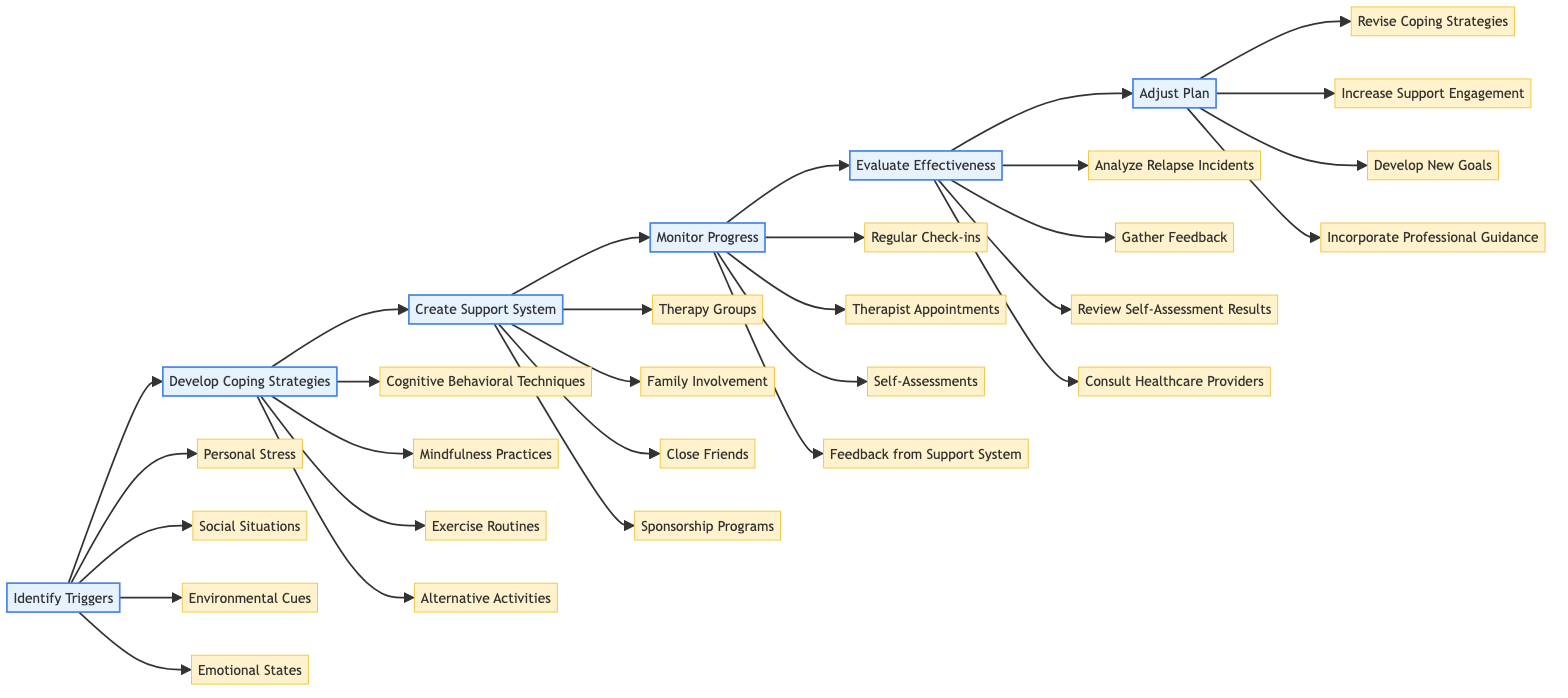What is the first step in the relapse prevention strategy? The first step in the flowchart is represented by the node labeled "Identify Triggers." This is the starting point of the horizontal flowchart.
Answer: Identify Triggers How many detailed points are listed under "Create Support System"? The "Create Support System" step has four detailed points listed below it, which are represented as nodes connected to it in the diagram.
Answer: 4 What are three examples of triggers identified in the diagram? The diagram provides four examples under the "Identify Triggers" step, such as Personal Stress, Social Situations, and Emotional States. Any three of these could be a valid answer to this question.
Answer: Personal Stress, Social Situations, Emotional States What comes after "Monitor Progress"? The next step after "Monitor Progress," which is placed further along the flowchart, is "Evaluate Effectiveness." This indicates the next action in the sequence.
Answer: Evaluate Effectiveness How does "Adjust Plan" relate to "Evaluate Effectiveness"? In the flowchart, "Adjust Plan" follows "Evaluate Effectiveness," indicating that it is the subsequent step that comes after evaluating how effective the previously implemented strategies have been.
Answer: Adjust Plan What is one method under "Develop Coping Strategies"? The "Develop Coping Strategies" step includes several methods in the detailed points, one of which is "Mindfulness Practices." This is one example of a coping strategy outlined in the diagram.
Answer: Mindfulness Practices What is the last detailed point listed under "Evaluate Effectiveness"? The last detailed point under the "Evaluate Effectiveness" step in the diagram is "Consult with Healthcare Providers," which is the fourth item connected to that step.
Answer: Consult with Healthcare Providers How many major steps are outlined in the relapse prevention strategy? The flowchart identifies six major steps in the relapse prevention strategy, each represented by a distinct node connected in a sequence from start to finish.
Answer: 6 Which step is responsible for gathering feedback? The "Evaluate Effectiveness" step is responsible for gathering feedback from the support network, as indicated by the details listed under it in the diagram.
Answer: Evaluate Effectiveness 